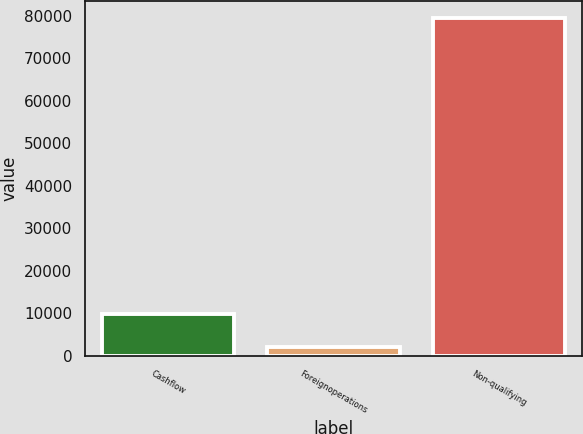Convert chart to OTSL. <chart><loc_0><loc_0><loc_500><loc_500><bar_chart><fcel>Cashflow<fcel>Foreignoperations<fcel>Non-qualifying<nl><fcel>9757.3<fcel>2005<fcel>79528<nl></chart> 